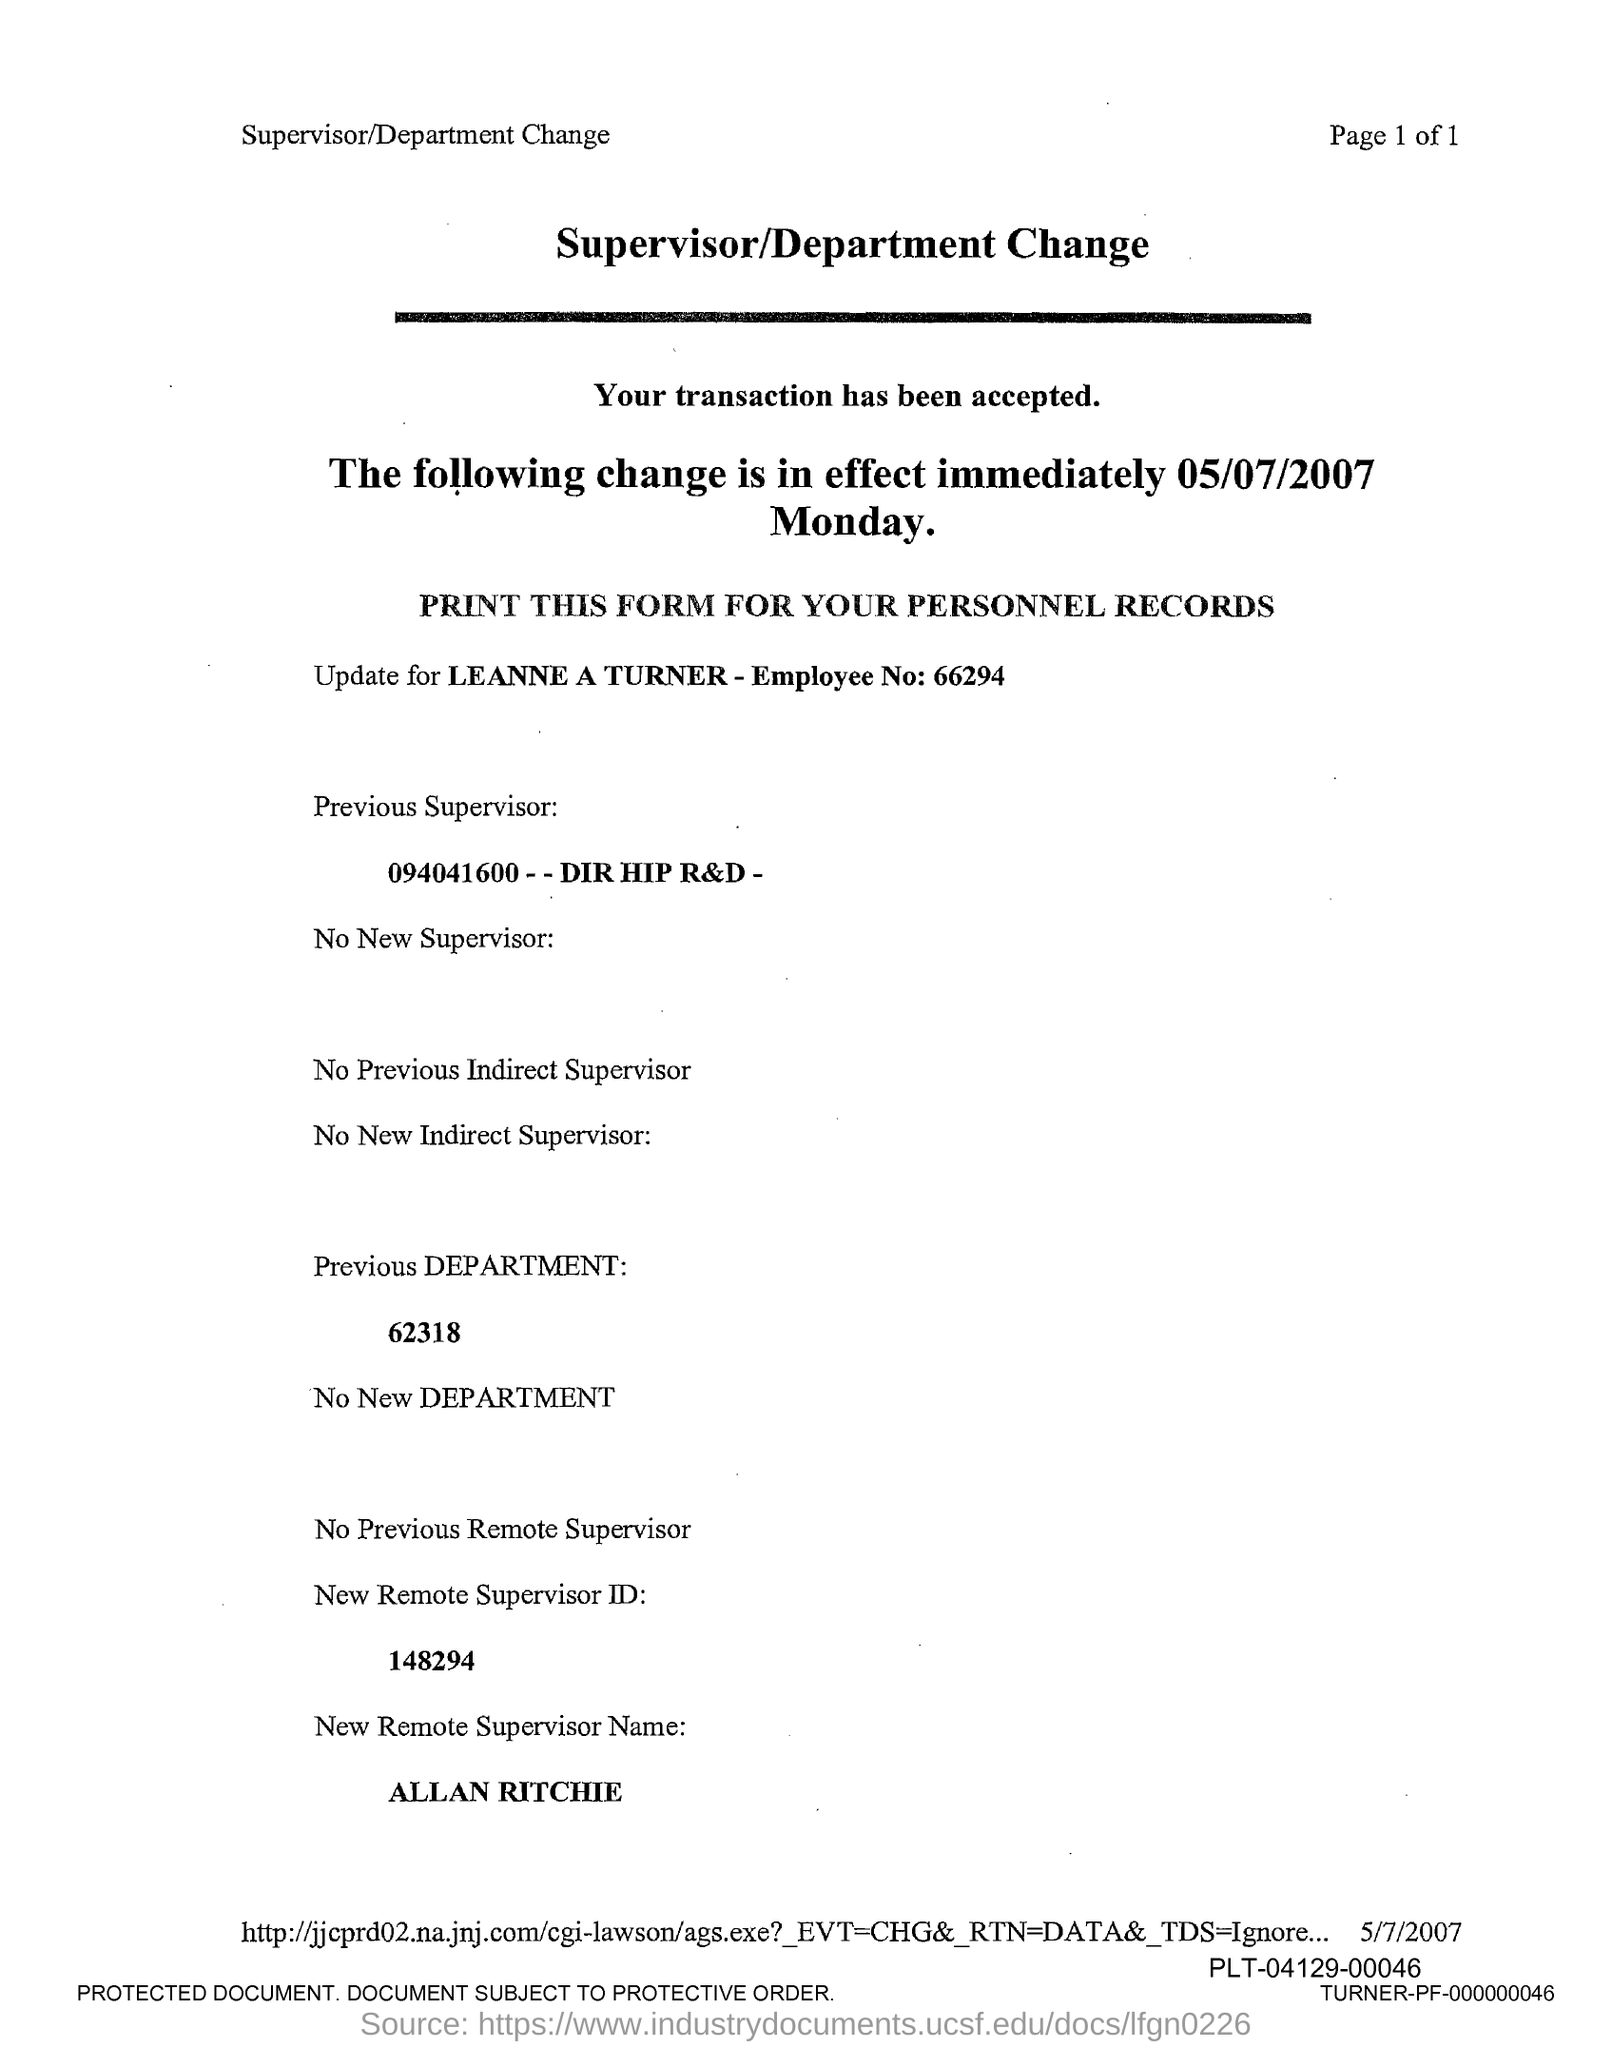What is the employee no. of Leanne Turner?
Your response must be concise. 66294. What is the new remote supervisor ID given in the form?
Your answer should be compact. 148294. What is the new remote supervisor name mentioned in the form?
Keep it short and to the point. Allan Ritchie. What is the Previous department no mentioned in the form?
Keep it short and to the point. 62318. 